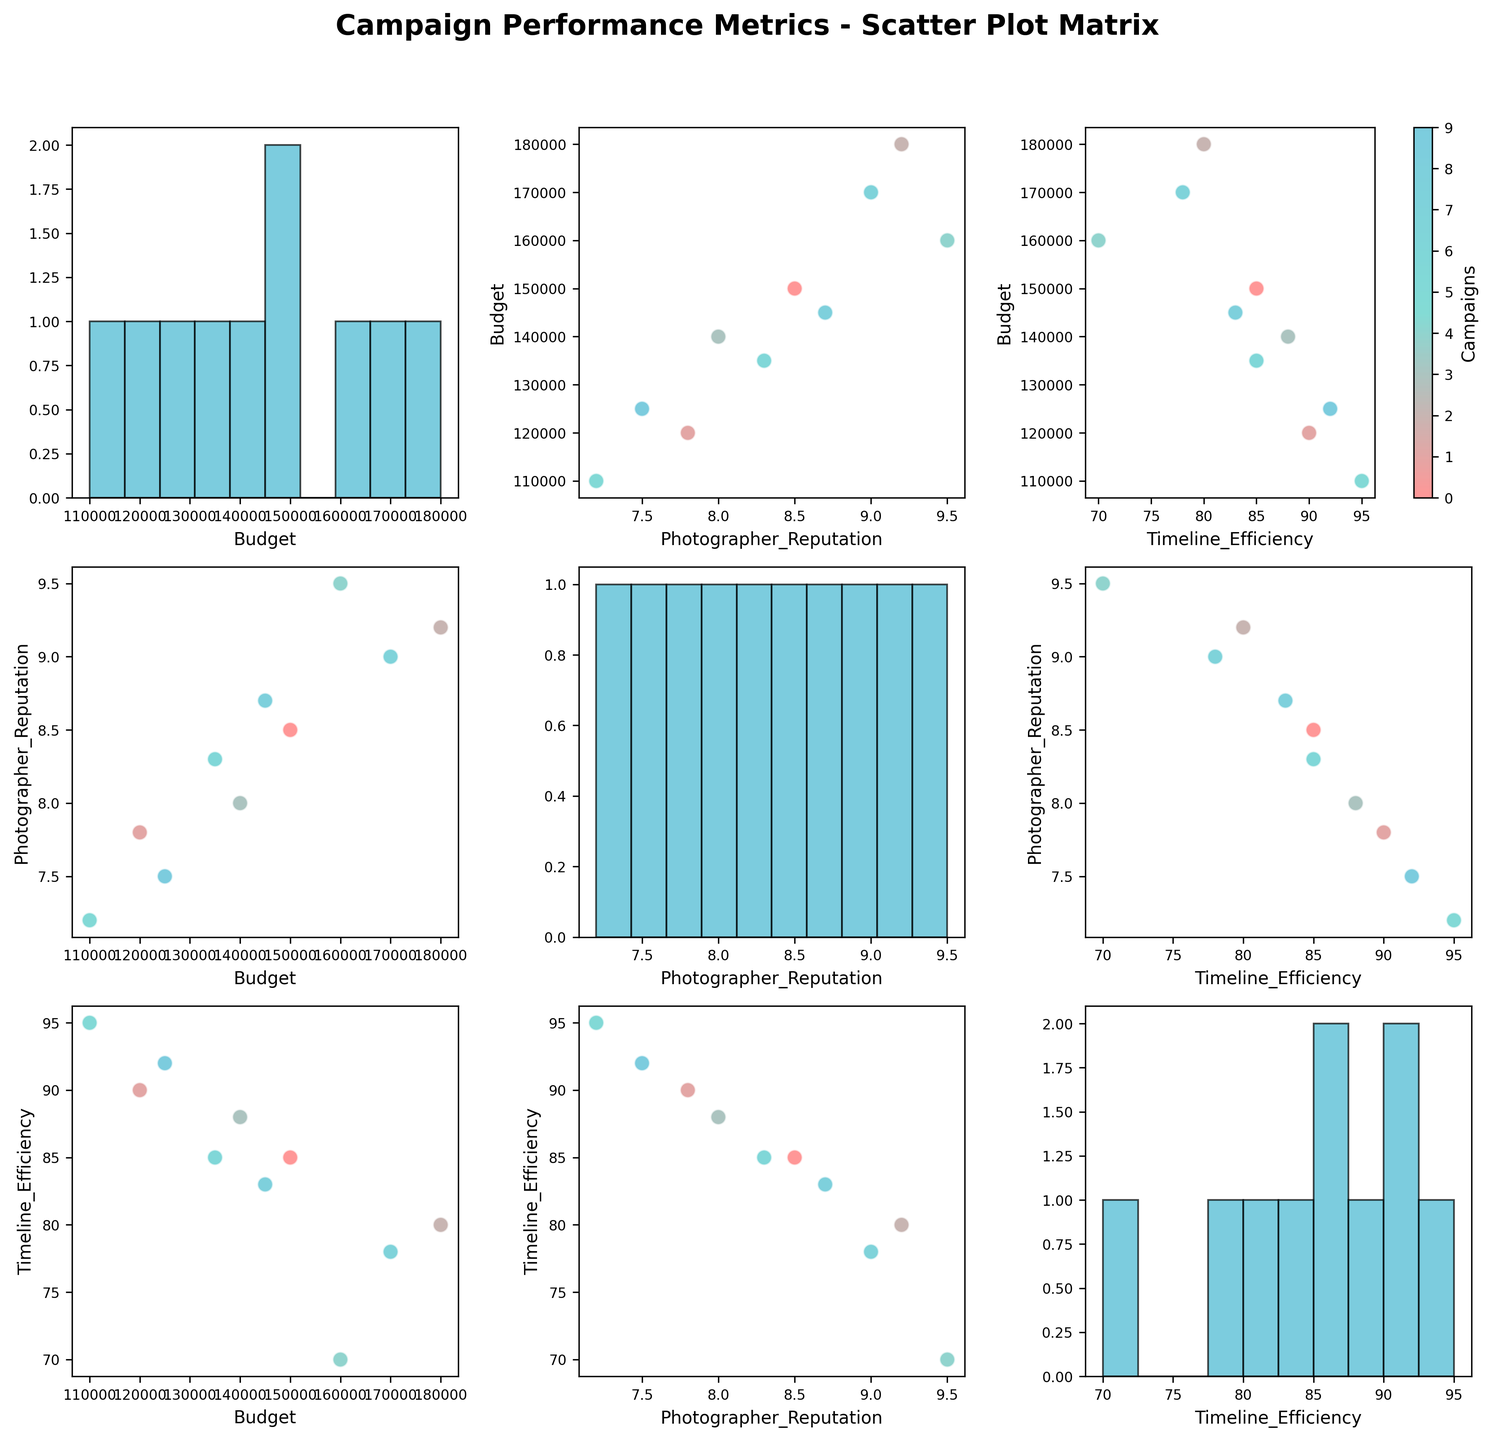What's the title of the figure? The title is located at the top of the figure and is usually in bold and larger font size for easy identification.
Answer: Campaign Performance Metrics - Scatter Plot Matrix How many histograms can you find in the plot? In a scatter plot matrix, histograms usually appear along the diagonal. Since there are three features, there should be three histograms on the diagonal of the matrix.
Answer: 3 Which variable combination shows the highest positive correlation? By visually inspecting the scatter plots, you can identify the pair with the most noticeable positive trend between the points.
Answer: Budget and Photographer Reputation What is the distribution shape of the Photographer Reputation? Look at the histogram on the diagonal corresponding to 'Photographer Reputation' to determine if it is skewed, normal, or another shape.
Answer: Slightly left-skewed Which campaign had the lowest budget and what was its value? Identify the point with the lowest value on the Budget axis and refer to its corresponding campaign. All points are colored distinctly for each campaign.
Answer: Campaign_F, \$110,000 Is there an evident trend between Budget and Timeline Efficiency? Check the scatter plot of Budget vs. Timeline Efficiency for patterns like upward, downward, or no trend.
Answer: No evident trend Between Timeline Efficiency and Photographer Reputation, which combination has more spread out data points? Compare the scatter plots for these variables. More spread means the points take up more space vertically and horizontally.
Answer: Timeline Efficiency and Photographer Reputation Do any campaigns overlap significantly in the scatter plot matrix? Look for points that are very close to or on top of each other in multiple sections of the matrix.
Answer: No What is the average Photographer Reputation rating for campaigns with a budget above \$150,000? Identify campaigns with budgets above \$150,000, note their Photographer Reputation ratings, and calculate the average: (9.2 + 9.5 + 9.0) / 3 = 9.23
Answer: 9.23 Does higher Photographer Reputation correlate with better Timeline Efficiency? Check the scatter plot for Photographer Reputation vs. Timeline Efficiency for any positive or negative trend.
Answer: Slight negative correlation 